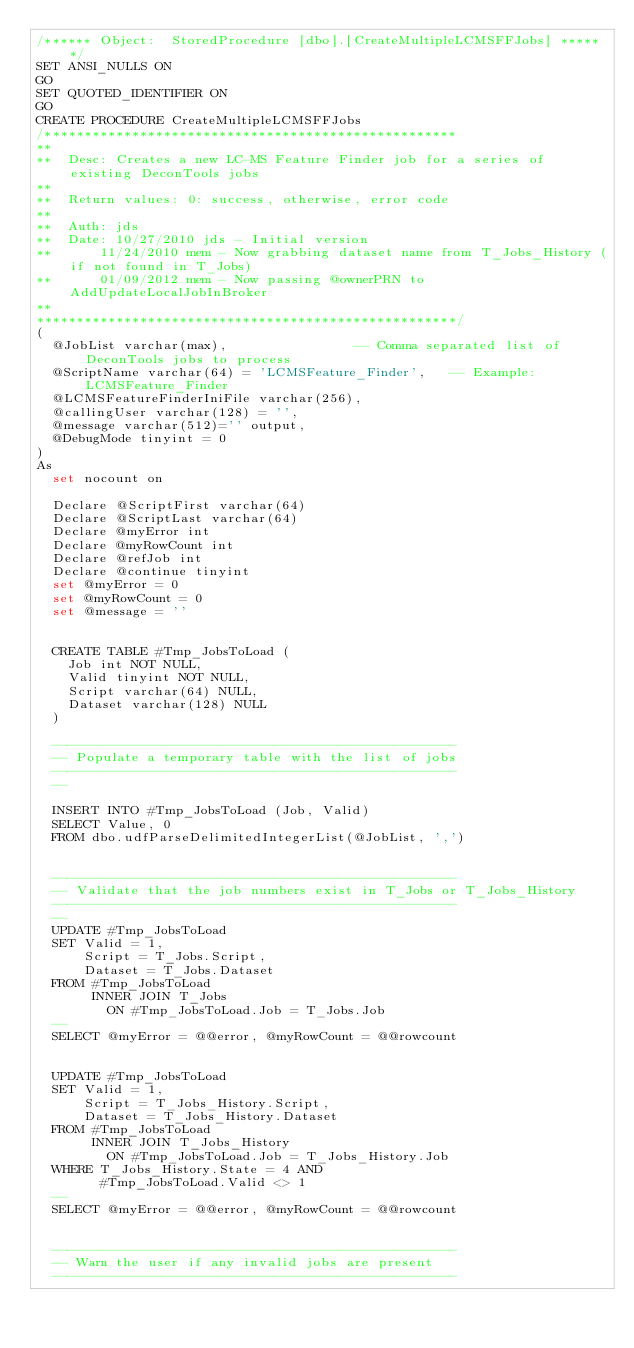Convert code to text. <code><loc_0><loc_0><loc_500><loc_500><_SQL_>/****** Object:  StoredProcedure [dbo].[CreateMultipleLCMSFFJobs] ******/
SET ANSI_NULLS ON
GO
SET QUOTED_IDENTIFIER ON
GO
CREATE PROCEDURE CreateMultipleLCMSFFJobs
/****************************************************
**
**	Desc:	Creates a new LC-MS Feature Finder job for a series of existing DeconTools jobs
**	
**	Return values: 0: success, otherwise, error code
**
**	Auth:	jds
**	Date:	10/27/2010 jds - Initial version
**			11/24/2010 mem - Now grabbing dataset name from T_Jobs_History (if not found in T_Jobs)
**			01/09/2012 mem - Now passing @ownerPRN to AddUpdateLocalJobInBroker
**    
*****************************************************/
(
	@JobList varchar(max),								-- Comma separated list of DeconTools jobs to process
	@ScriptName varchar(64) = 'LCMSFeature_Finder',		-- Example: LCMSFeature_Finder
	@LCMSFeatureFinderIniFile varchar(256),		
	@callingUser varchar(128) = '',					
	@message varchar(512)='' output,			
	@DebugMode tinyint = 0						
)
As
	set nocount on
	
	Declare @ScriptFirst varchar(64)
	Declare @ScriptLast varchar(64)
	Declare @myError int
	Declare @myRowCount int
	Declare @refJob int
	Declare @continue tinyint
	set @myError = 0
	set @myRowCount = 0
	set @message = ''


	CREATE TABLE #Tmp_JobsToLoad (
		Job int NOT NULL,
		Valid tinyint NOT NULL,
		Script varchar(64) NULL,
		Dataset varchar(128) NULL
	)
	
	---------------------------------------------------
	-- Populate a temporary table with the list of jobs
	---------------------------------------------------
	--

	INSERT INTO #Tmp_JobsToLoad (Job, Valid)
	SELECT Value, 0
	FROM dbo.udfParseDelimitedIntegerList(@JobList, ',')
	

	---------------------------------------------------
	-- Validate that the job numbers exist in T_Jobs or T_Jobs_History
	---------------------------------------------------
	--
	UPDATE #Tmp_JobsToLoad
	SET Valid = 1,
	    Script = T_Jobs.Script,
	    Dataset = T_Jobs.Dataset
	FROM #Tmp_JobsToLoad
	     INNER JOIN T_Jobs
	       ON #Tmp_JobsToLoad.Job = T_Jobs.Job
	--
	SELECT @myError = @@error, @myRowCount = @@rowcount
	

	UPDATE #Tmp_JobsToLoad
	SET Valid = 1,
	    Script = T_Jobs_History.Script,
	    Dataset = T_Jobs_History.Dataset
	FROM #Tmp_JobsToLoad
	     INNER JOIN T_Jobs_History
	       ON #Tmp_JobsToLoad.Job = T_Jobs_History.Job
	WHERE T_Jobs_History.State = 4 AND
	      #Tmp_JobsToLoad.Valid <> 1
	--
	SELECT @myError = @@error, @myRowCount = @@rowcount
	

	---------------------------------------------------
	-- Warn the user if any invalid jobs are present
	---------------------------------------------------</code> 